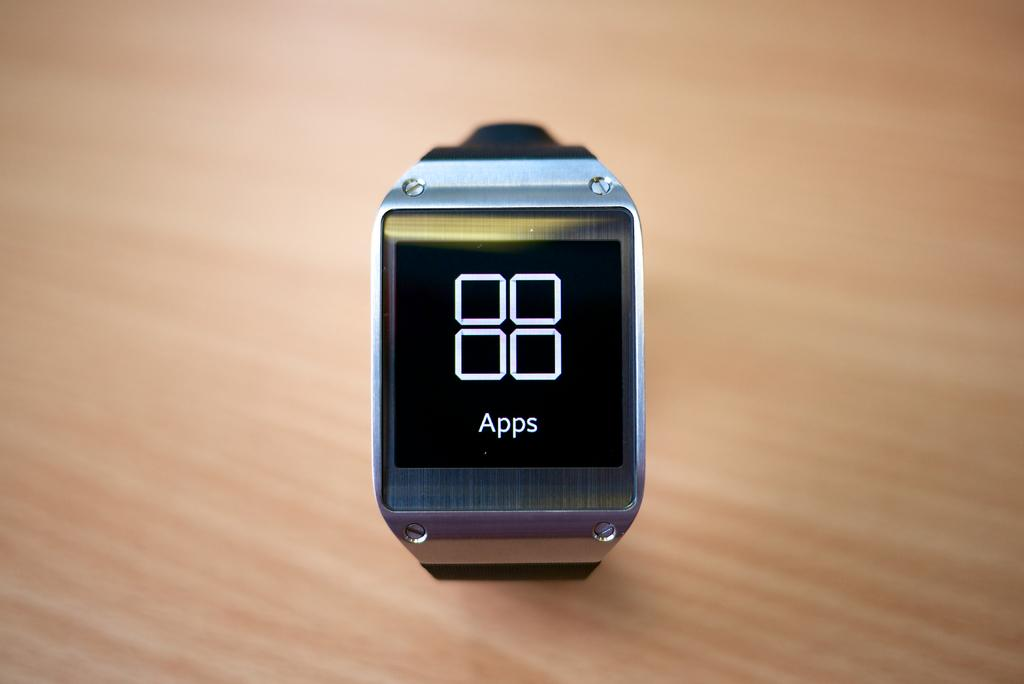<image>
Offer a succinct explanation of the picture presented. Square watch which has the word Apps on the face. 